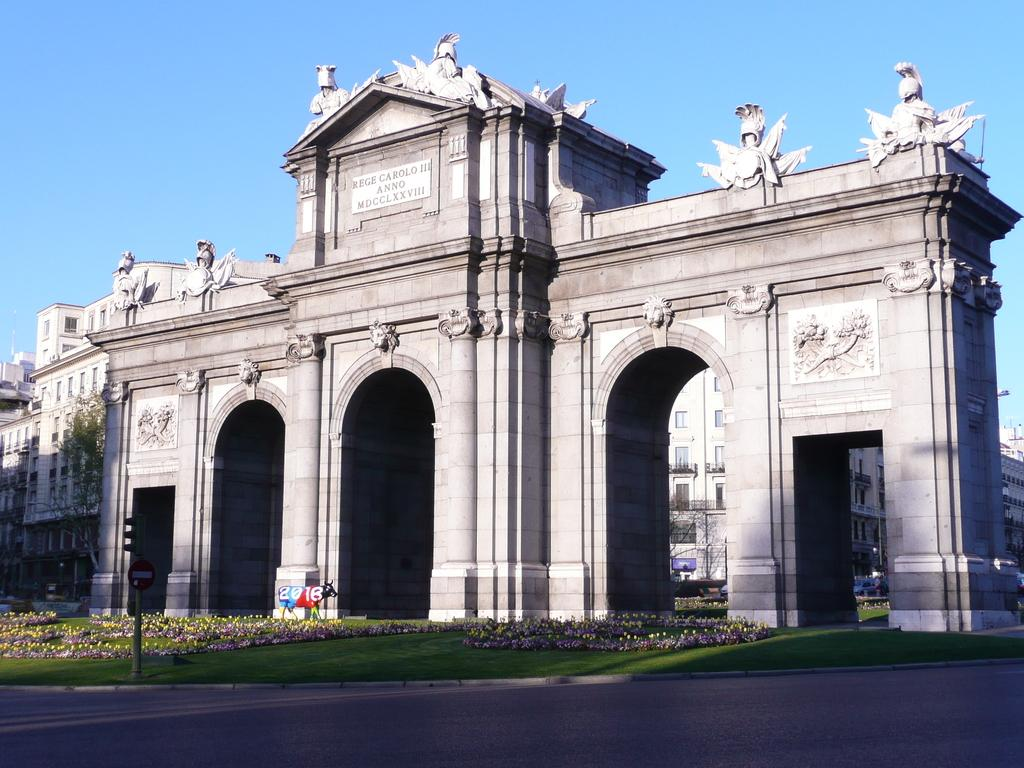What is located in the center of the image? There are buildings and sculptures in the center of the image. What can be seen at the bottom of the image? There is a road, grass, flowers, a pole, and a board at the bottom of the image. What is visible at the top of the image? The sky is visible at the top of the image. Can you tell me how many boats are docked at the harbor in the image? There is no harbor present in the image; it features buildings, sculptures, a road, grass, flowers, a pole, and a board. What type of leather is used to make the shoes worn by the people in the image? There are no people or shoes visible in the image. 